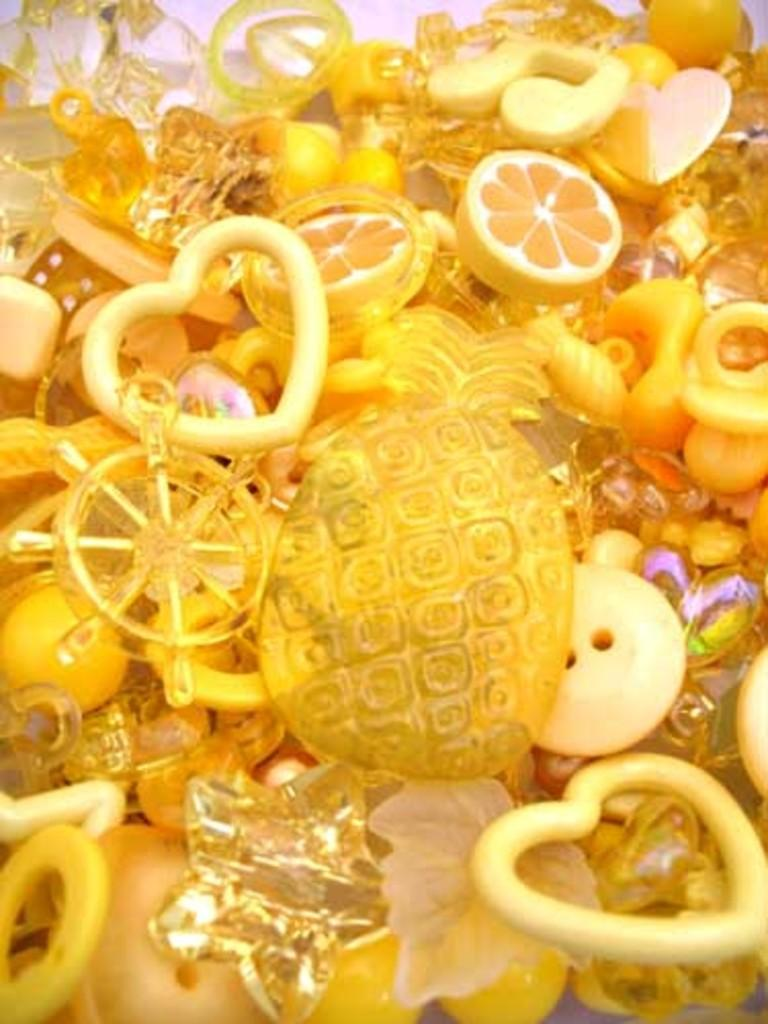What is the main object in the image? There is a button in the image. What else can be seen in the image besides the button? There are symbols, toy items, and rings in the image. How are the objects arranged in the image? The objects are arranged on a white color sheet. What is the color of the background in the image? The background of the image is white in color. Can you see an owl sitting on the roof in the image? There is no owl or roof present in the image. How many ladybugs are crawling on the rings in the image? There are no ladybugs present in the image. 